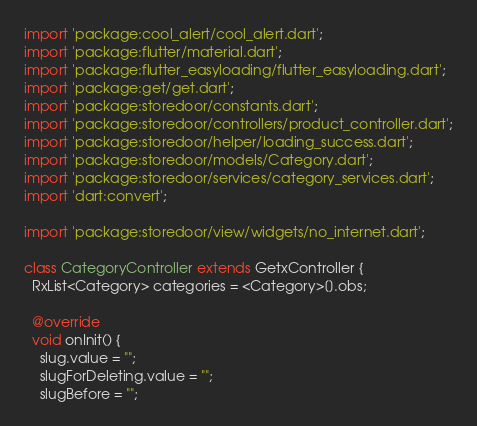Convert code to text. <code><loc_0><loc_0><loc_500><loc_500><_Dart_>import 'package:cool_alert/cool_alert.dart';
import 'package:flutter/material.dart';
import 'package:flutter_easyloading/flutter_easyloading.dart';
import 'package:get/get.dart';
import 'package:storedoor/constants.dart';
import 'package:storedoor/controllers/product_controller.dart';
import 'package:storedoor/helper/loading_success.dart';
import 'package:storedoor/models/Category.dart';
import 'package:storedoor/services/category_services.dart';
import 'dart:convert';

import 'package:storedoor/view/widgets/no_internet.dart';

class CategoryController extends GetxController {
  RxList<Category> categories = <Category>[].obs;

  @override
  void onInit() {
    slug.value = "";
    slugForDeleting.value = "";
    slugBefore = "";</code> 